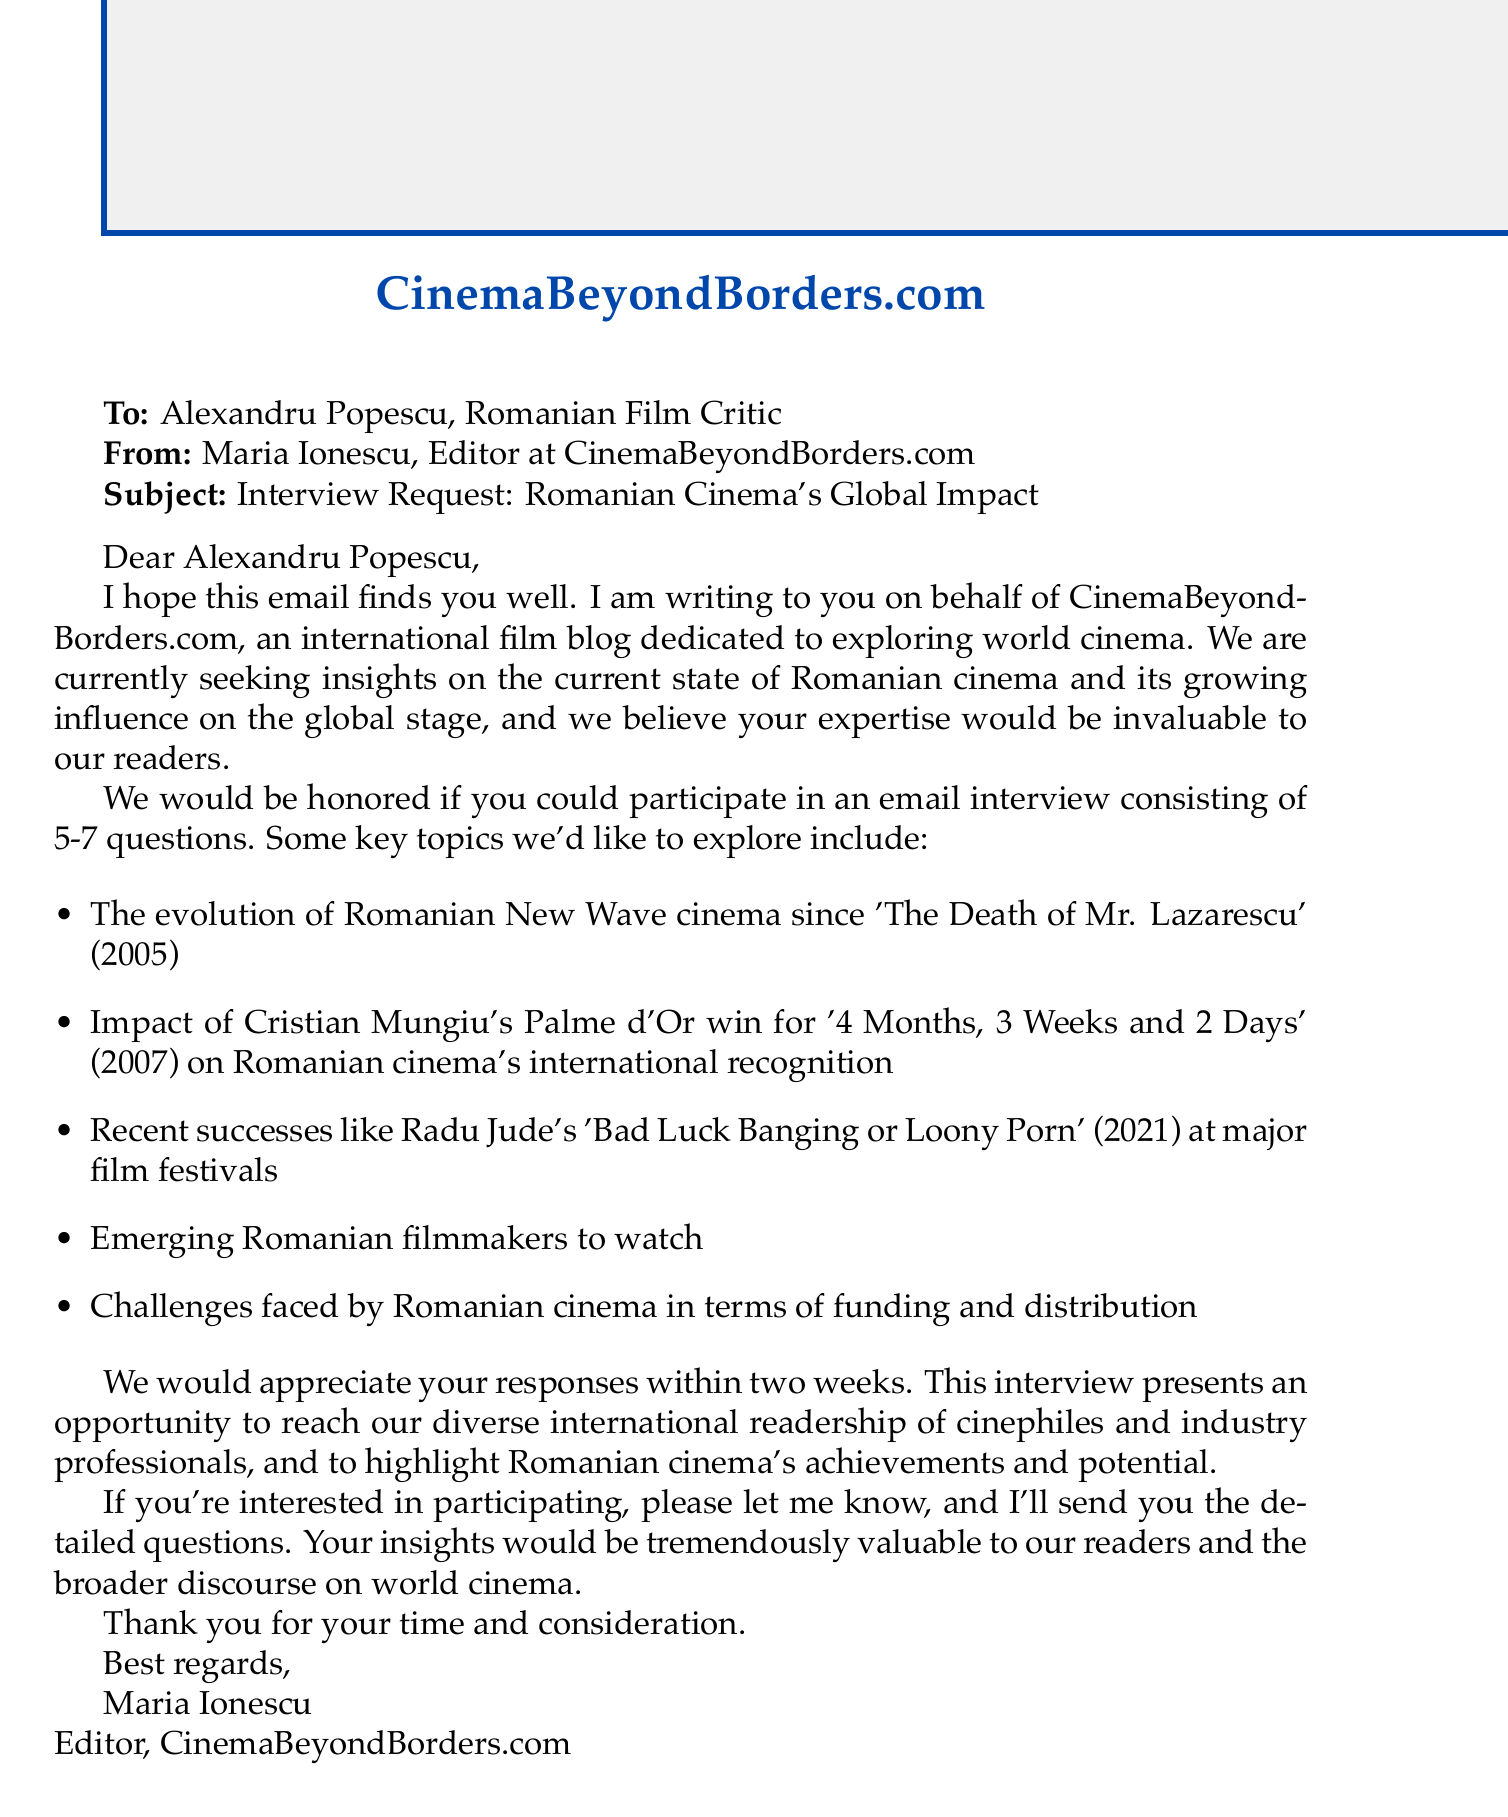What is the name of the film blog? The film blog is named CinemaBeyondBorders.com, as stated in the introduction.
Answer: CinemaBeyondBorders.com Who is the sender of the email? The sender, as mentioned at the beginning, is Maria Ionescu, Editor at CinemaBeyondBorders.com.
Answer: Maria Ionescu What is the subject of the email? The subject of the email is explicitly stated as "Interview Request: Romanian Cinema's Global Impact."
Answer: Interview Request: Romanian Cinema's Global Impact When should the responses be provided? The document specifies that the interview responses should be received within two weeks.
Answer: Within two weeks Which specific film marked an evolution in Romanian New Wave cinema? The email mentions 'The Death of Mr. Lazarescu' (2005) as significant in this context.
Answer: The Death of Mr. Lazarescu What is one recent success mentioned in the key topics? The email notes Radu Jude's 'Bad Luck Banging or Loony Porn' (2021) as a recent success.
Answer: Bad Luck Banging or Loony Porn What kind of format will the interview take? The document states that the interview will consist of 5-7 questions via email.
Answer: 5-7 questions via email What benefit is mentioned for the interview participant? The email highlights the opportunity to reach a diverse international readership of cinephiles and industry professionals.
Answer: Reach our diverse international readership What challenge is faced by Romanian cinema as per the key topics? The document mentions challenges in terms of funding and distribution for Romanian cinema.
Answer: Funding and distribution 